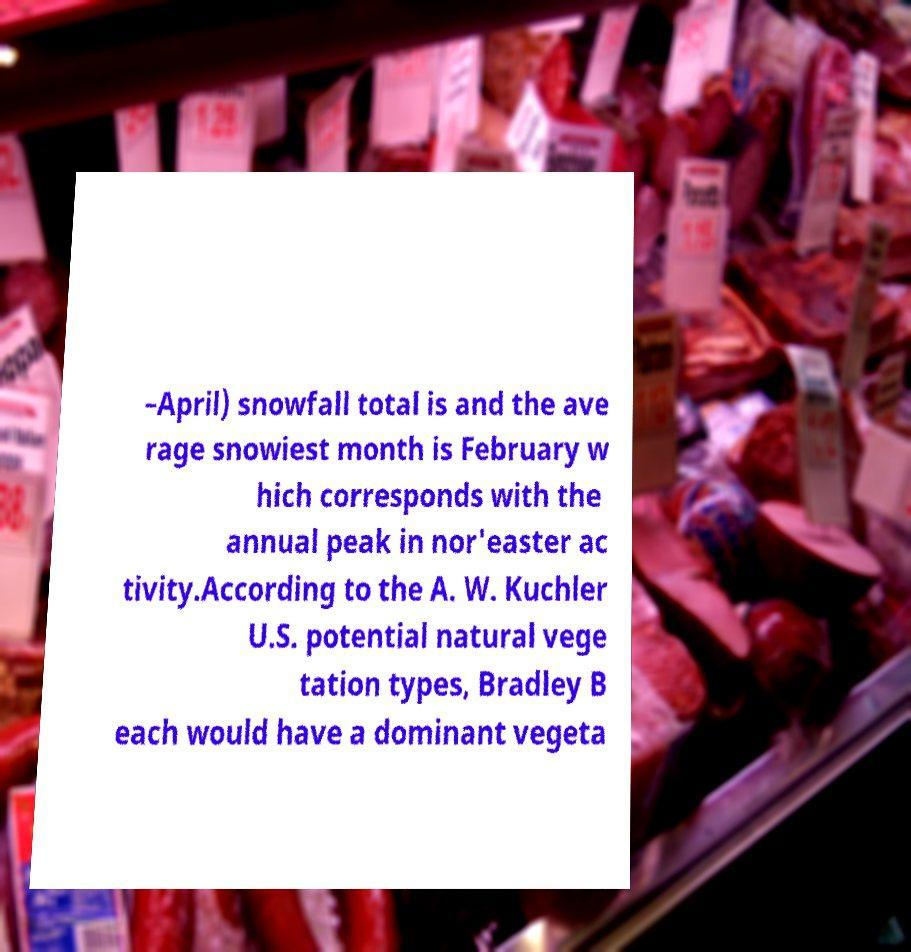Please identify and transcribe the text found in this image. –April) snowfall total is and the ave rage snowiest month is February w hich corresponds with the annual peak in nor'easter ac tivity.According to the A. W. Kuchler U.S. potential natural vege tation types, Bradley B each would have a dominant vegeta 